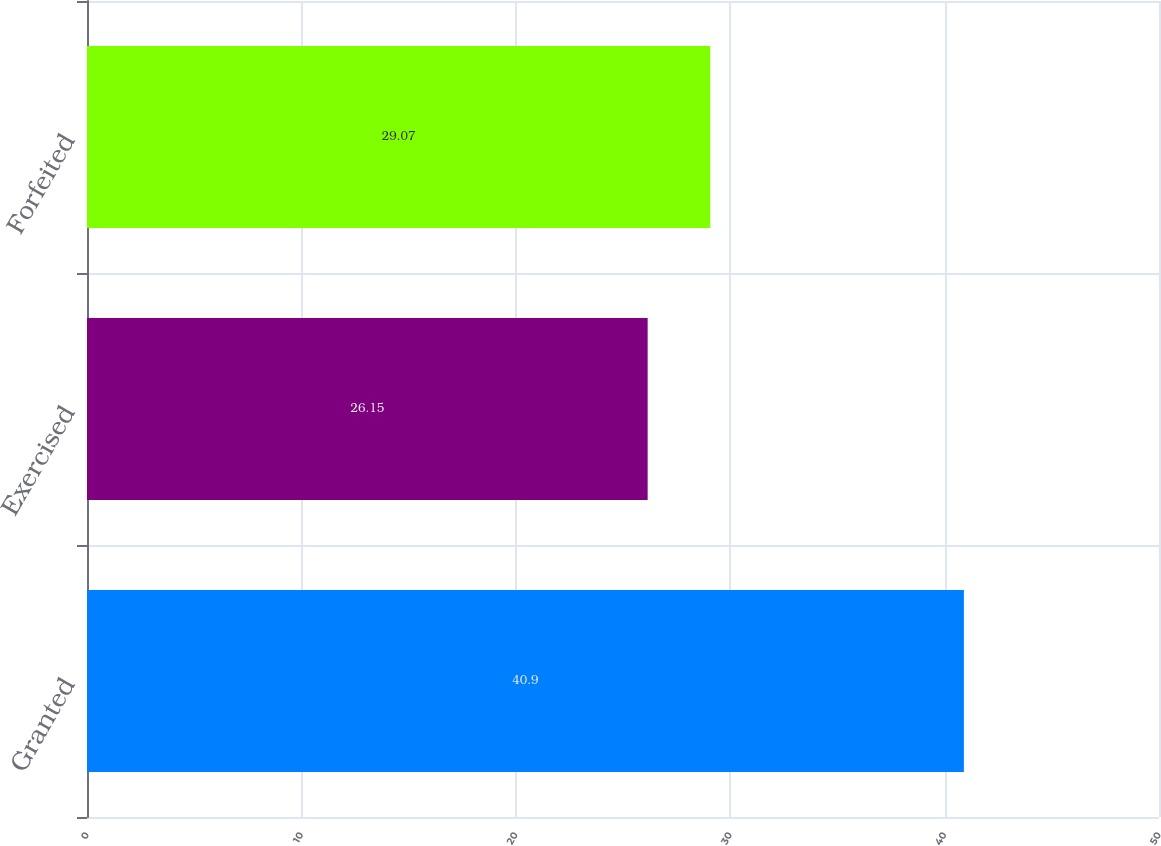<chart> <loc_0><loc_0><loc_500><loc_500><bar_chart><fcel>Granted<fcel>Exercised<fcel>Forfeited<nl><fcel>40.9<fcel>26.15<fcel>29.07<nl></chart> 